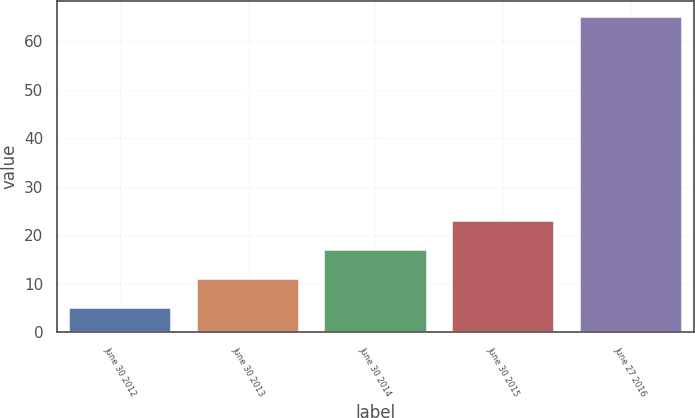Convert chart to OTSL. <chart><loc_0><loc_0><loc_500><loc_500><bar_chart><fcel>June 30 2012<fcel>June 30 2013<fcel>June 30 2014<fcel>June 30 2015<fcel>June 27 2016<nl><fcel>5<fcel>11<fcel>17<fcel>23<fcel>65<nl></chart> 